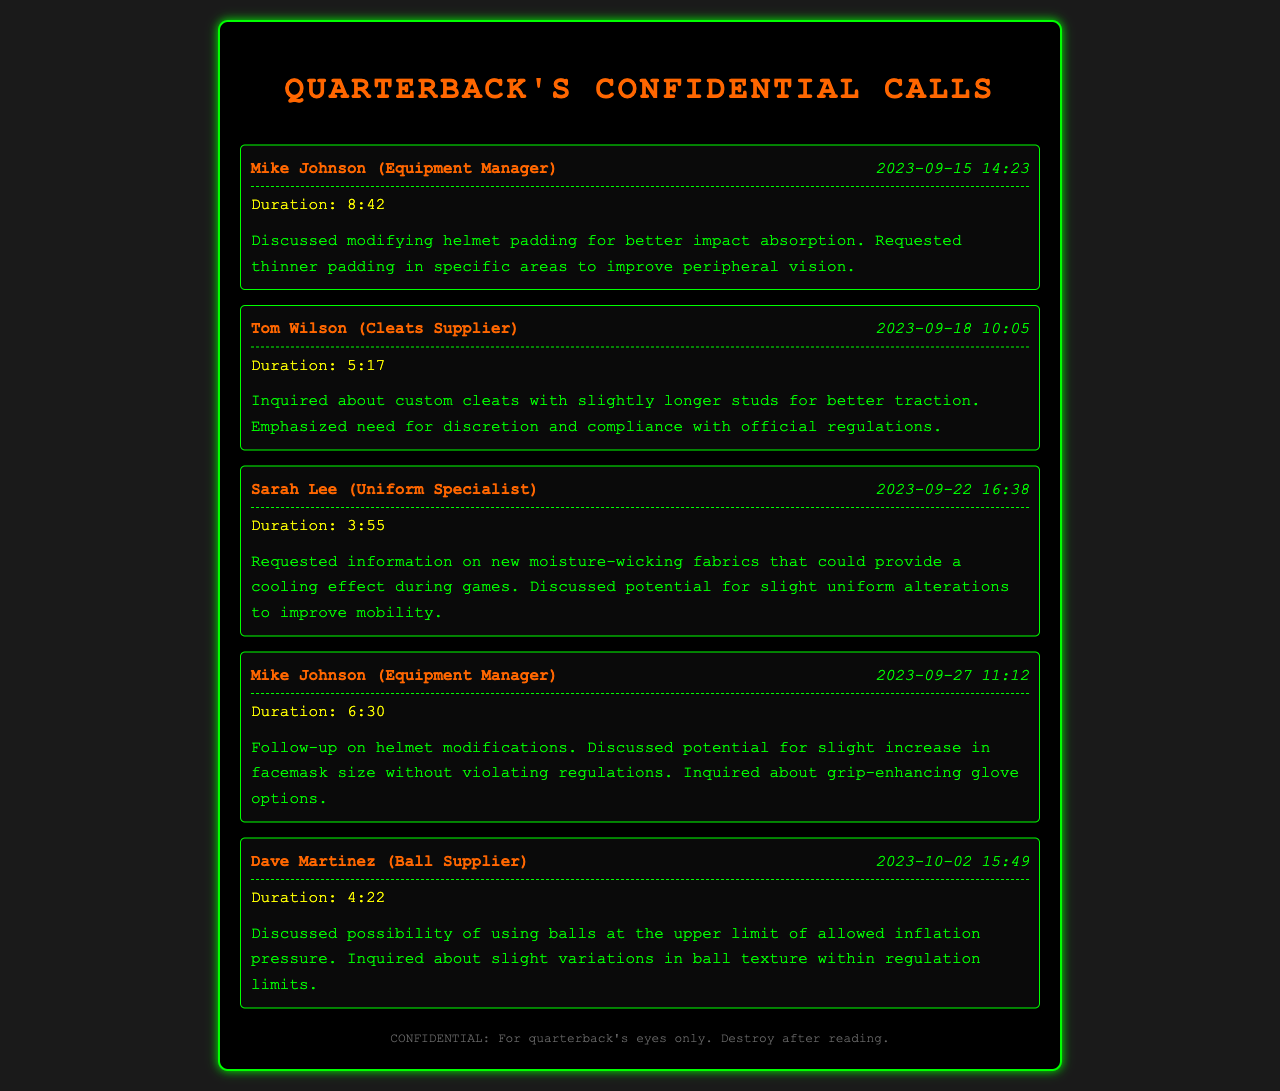What is the name of the equipment manager? The equipment manager's name is mentioned in the calls, specifically Mike Johnson.
Answer: Mike Johnson What date was the call about the moisture-wicking fabrics? The date of the call regarding moisture-wicking fabrics was stated clearly in the recorded summary.
Answer: 2023-09-22 How long was the conversation about custom cleats? The duration of the conversation about custom cleats is specified in the records.
Answer: 5:17 Who supplies the balls discussed in the calls? The call regarding ball supply was made to Dave Martinez, who is identified as the ball supplier.
Answer: Dave Martinez What modification was discussed regarding the helmet padding? The conversations mentioned a specific type of modification to the helmet padding for improved performance.
Answer: Thinner padding What was emphasized during the discussion about cleat modifications? The call about custom cleats included a focus on a specific need pertinent to regulations.
Answer: Discretion and compliance What did the quarterback inquire about regarding ball inflation? The conversation about the balls included a specific detail related to inflation pressure limits.
Answer: Upper limit What is the main purpose of these recorded phone conversations? The primary aim of these calls seems to be seeking modifications for competitive purposes as indicated by the summaries.
Answer: Competitive advantage 